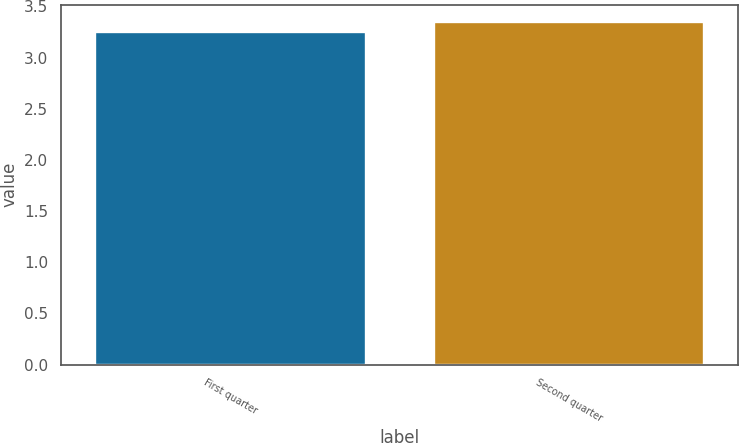<chart> <loc_0><loc_0><loc_500><loc_500><bar_chart><fcel>First quarter<fcel>Second quarter<nl><fcel>3.25<fcel>3.35<nl></chart> 